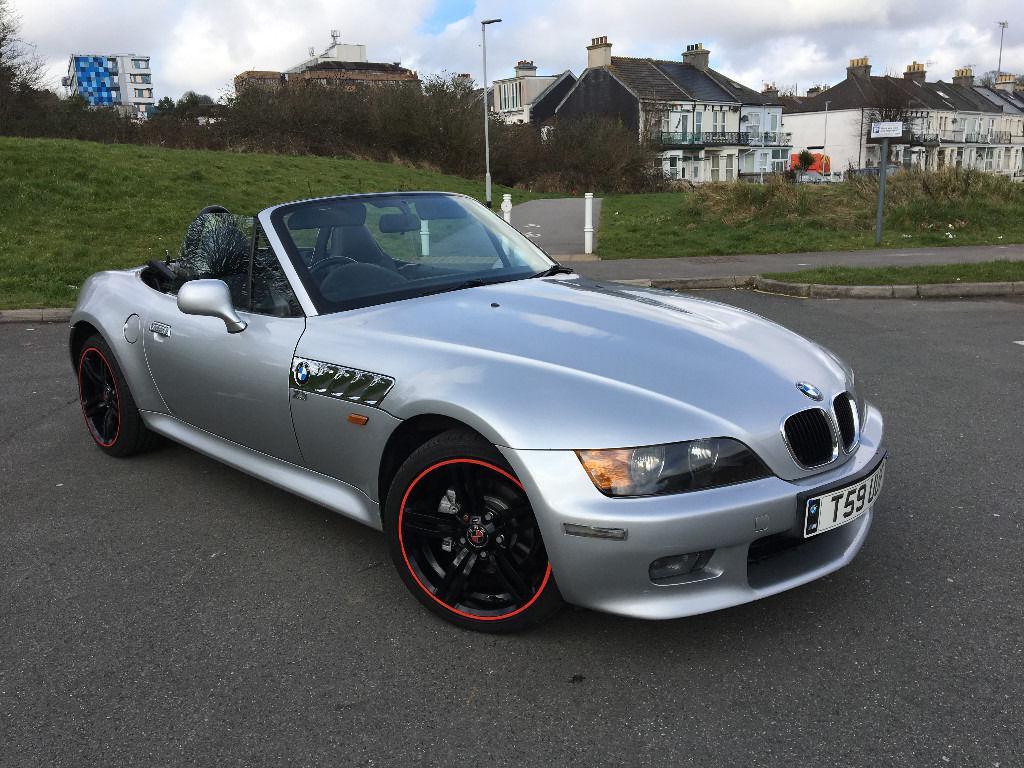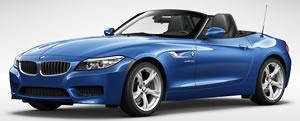The first image is the image on the left, the second image is the image on the right. Analyze the images presented: Is the assertion "One of the cars is facing the left and has red seats while the other car faces the right and has beige seats." valid? Answer yes or no. No. The first image is the image on the left, the second image is the image on the right. For the images shown, is this caption "The left image contains a white convertible that is parked facing towards the left." true? Answer yes or no. No. 